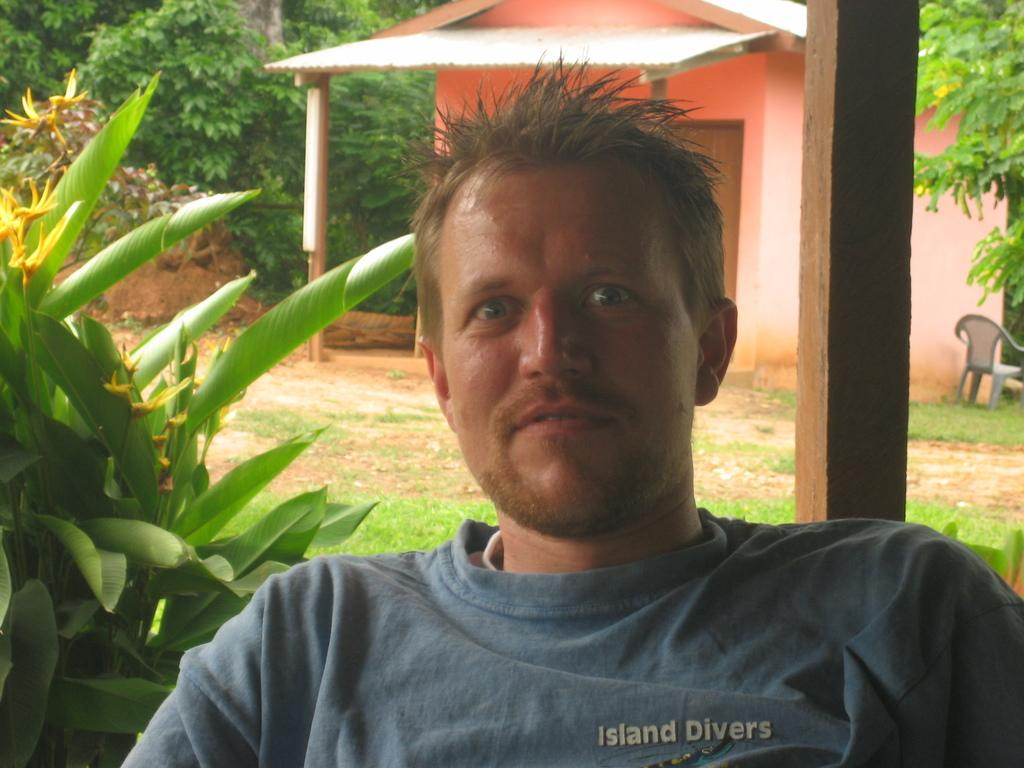What is the man in the image doing? The man is sitting on a chair in the image. What can be seen on the left side of the image? There are plants on the left side of the image. What is visible in the background of the image? There is a house and trees in the background of the image. What type of art can be seen hanging on the wall behind the man? There is no art visible in the image; it only shows a man sitting on a chair, plants on the left side, and a house and trees in the background. 